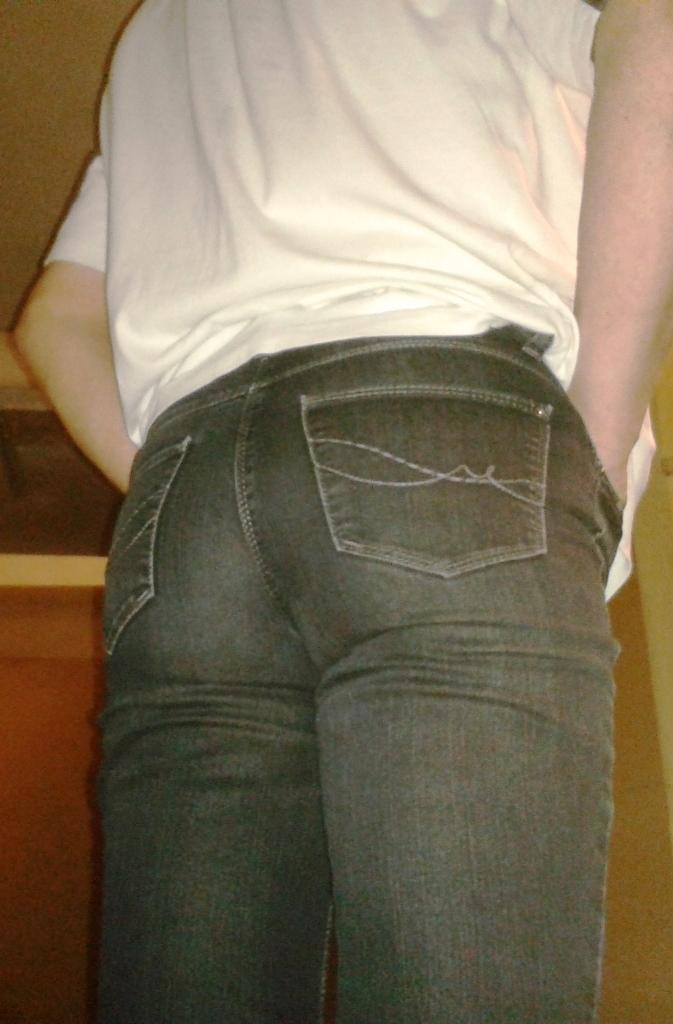Could you give a brief overview of what you see in this image? In this image we can see a person. In the background there is an object. 